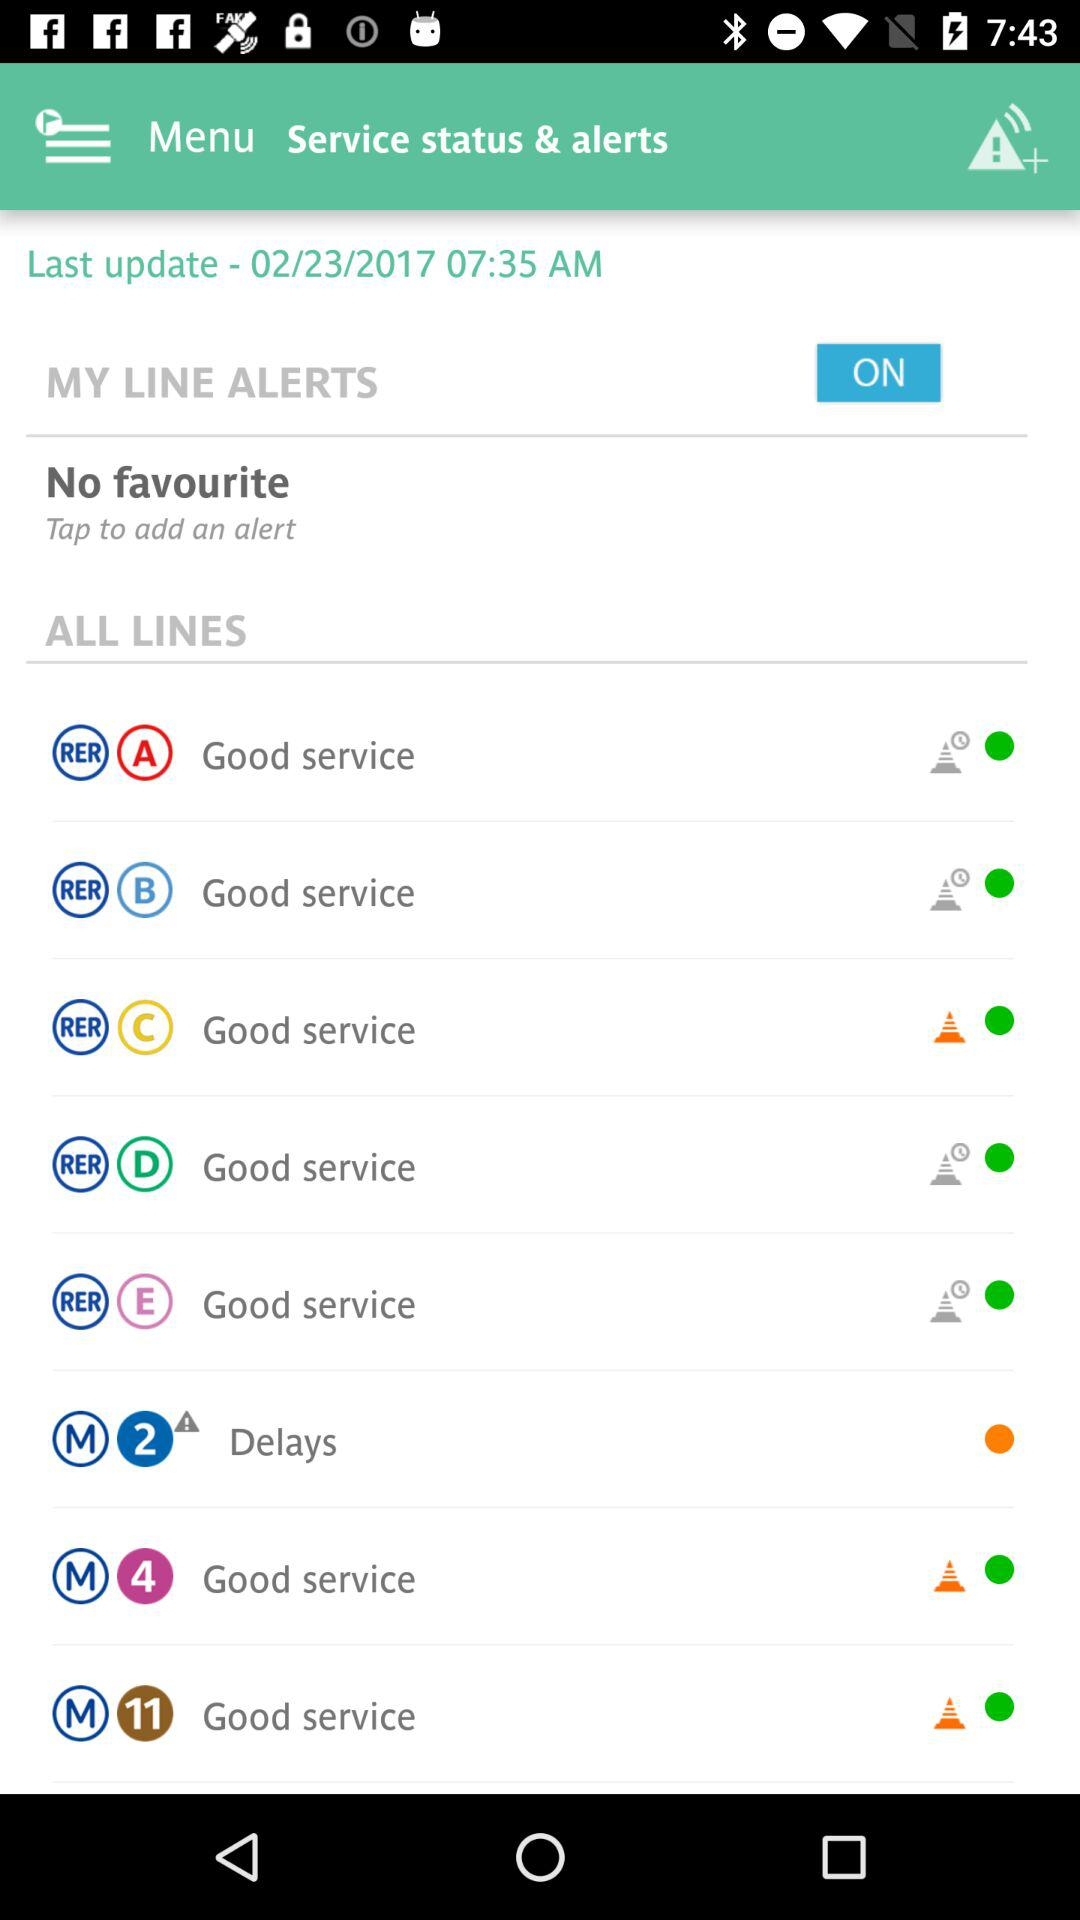What is the status of the "MY LINE ALERTS"? The status is "ON". 